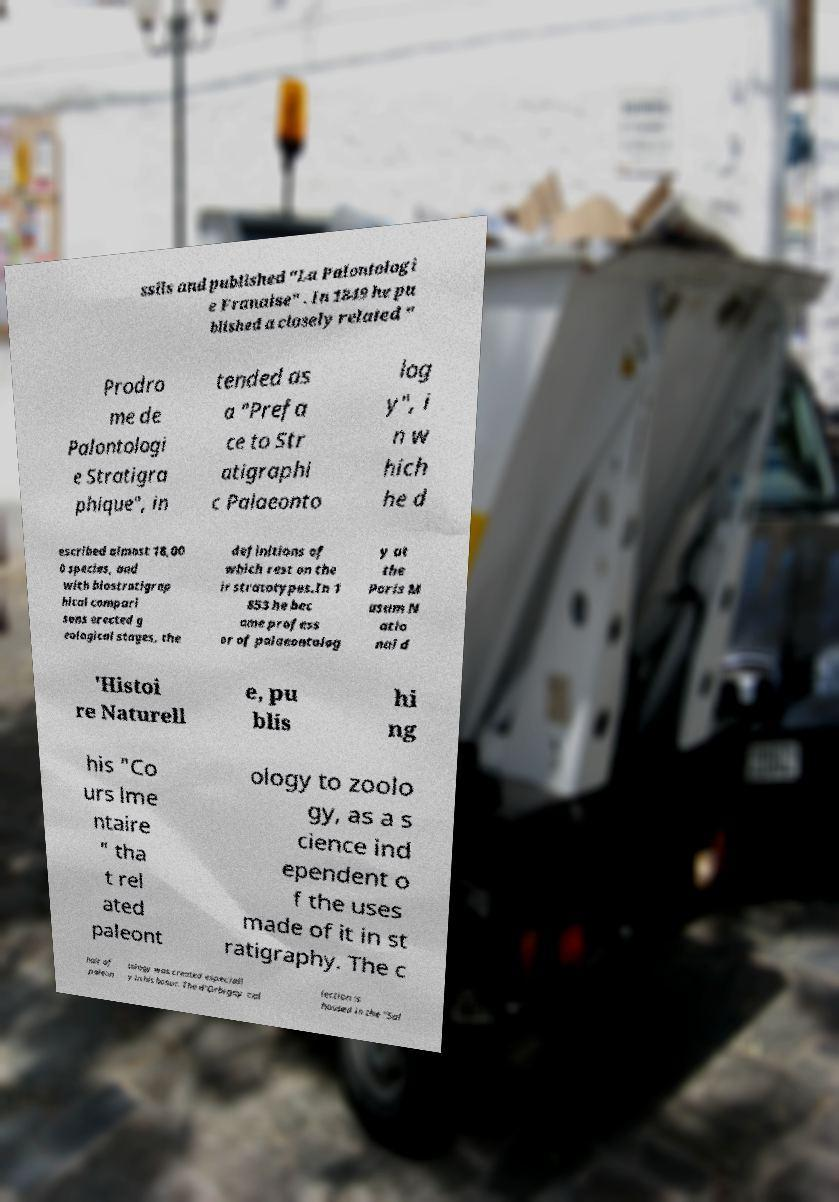I need the written content from this picture converted into text. Can you do that? ssils and published "La Palontologi e Franaise" . In 1849 he pu blished a closely related " Prodro me de Palontologi e Stratigra phique", in tended as a "Prefa ce to Str atigraphi c Palaeonto log y", i n w hich he d escribed almost 18,00 0 species, and with biostratigrap hical compari sons erected g eological stages, the definitions of which rest on the ir stratotypes.In 1 853 he bec ame profess or of palaeontolog y at the Paris M usum N atio nal d 'Histoi re Naturell e, pu blis hi ng his "Co urs lme ntaire " tha t rel ated paleont ology to zoolo gy, as a s cience ind ependent o f the uses made of it in st ratigraphy. The c hair of paleon tology was created especiall y in his honor. The d'Orbigny col lection is housed in the "Sal 